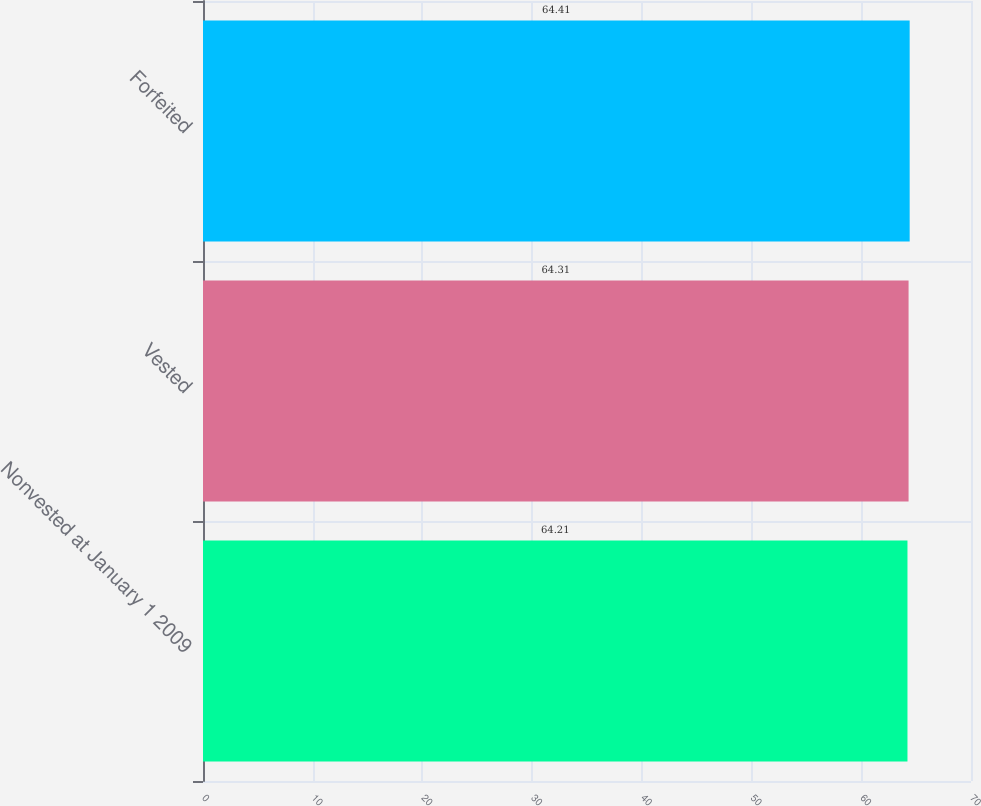Convert chart. <chart><loc_0><loc_0><loc_500><loc_500><bar_chart><fcel>Nonvested at January 1 2009<fcel>Vested<fcel>Forfeited<nl><fcel>64.21<fcel>64.31<fcel>64.41<nl></chart> 